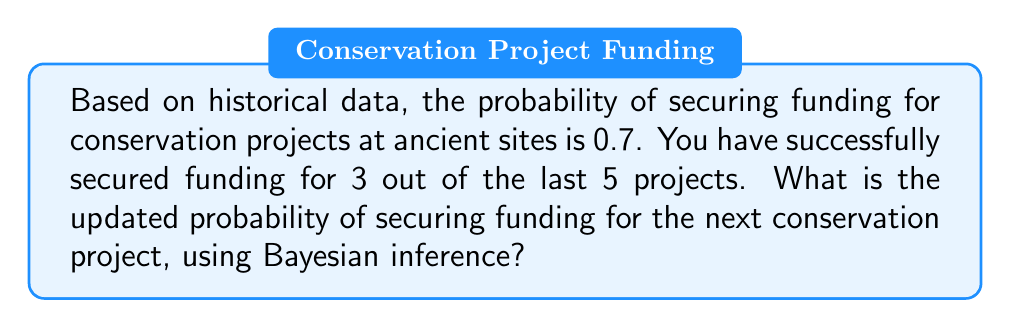Help me with this question. To solve this problem, we'll use Bayes' theorem. Let's define our events:

A: Securing funding for a project
B: The observed data (3 successes out of 5 trials)

We want to find P(A|B), the posterior probability of securing funding given our recent experience.

Bayes' theorem states:

$$P(A|B) = \frac{P(B|A) \cdot P(A)}{P(B)}$$

Where:
P(A) = 0.7 (prior probability of securing funding)
P(B|A) = Probability of observing 3 successes out of 5 trials, given the true probability is 0.7
P(B) = Overall probability of observing 3 successes out of 5 trials

Step 1: Calculate P(B|A)
We can use the binomial probability formula:
$$P(B|A) = \binom{5}{3} \cdot 0.7^3 \cdot (1-0.7)^2 = 10 \cdot 0.343 \cdot 0.09 = 0.3087$$

Step 2: Calculate P(B)
We need to consider both cases: when A is true and when A is false.
$$P(B) = P(B|A) \cdot P(A) + P(B|\text{not }A) \cdot P(\text{not }A)$$
$$P(B) = 0.3087 \cdot 0.7 + \binom{5}{3} \cdot 0.3^3 \cdot 0.7^2 \cdot 0.3$$
$$P(B) = 0.21609 + 0.03078 = 0.24687$$

Step 3: Apply Bayes' theorem
$$P(A|B) = \frac{0.3087 \cdot 0.7}{0.24687} = 0.8752$$

Therefore, the updated probability of securing funding for the next project is approximately 0.8752 or 87.52%.
Answer: The updated probability of securing funding for the next conservation project is approximately 0.8752 or 87.52%. 